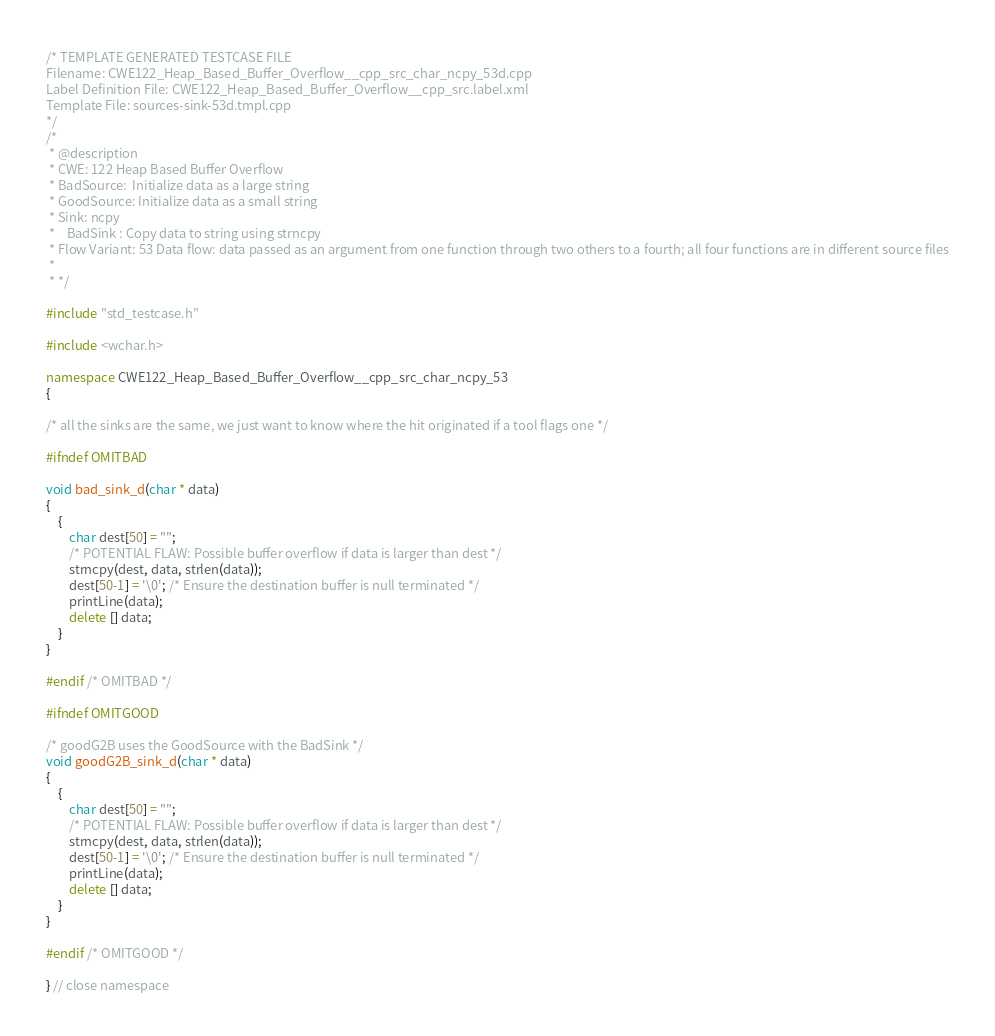Convert code to text. <code><loc_0><loc_0><loc_500><loc_500><_C++_>/* TEMPLATE GENERATED TESTCASE FILE
Filename: CWE122_Heap_Based_Buffer_Overflow__cpp_src_char_ncpy_53d.cpp
Label Definition File: CWE122_Heap_Based_Buffer_Overflow__cpp_src.label.xml
Template File: sources-sink-53d.tmpl.cpp
*/
/*
 * @description
 * CWE: 122 Heap Based Buffer Overflow
 * BadSource:  Initialize data as a large string
 * GoodSource: Initialize data as a small string
 * Sink: ncpy
 *    BadSink : Copy data to string using strncpy
 * Flow Variant: 53 Data flow: data passed as an argument from one function through two others to a fourth; all four functions are in different source files
 *
 * */

#include "std_testcase.h"

#include <wchar.h>

namespace CWE122_Heap_Based_Buffer_Overflow__cpp_src_char_ncpy_53
{

/* all the sinks are the same, we just want to know where the hit originated if a tool flags one */

#ifndef OMITBAD

void bad_sink_d(char * data)
{
    {
        char dest[50] = "";
        /* POTENTIAL FLAW: Possible buffer overflow if data is larger than dest */
        strncpy(dest, data, strlen(data));
        dest[50-1] = '\0'; /* Ensure the destination buffer is null terminated */
        printLine(data);
        delete [] data;
    }
}

#endif /* OMITBAD */

#ifndef OMITGOOD

/* goodG2B uses the GoodSource with the BadSink */
void goodG2B_sink_d(char * data)
{
    {
        char dest[50] = "";
        /* POTENTIAL FLAW: Possible buffer overflow if data is larger than dest */
        strncpy(dest, data, strlen(data));
        dest[50-1] = '\0'; /* Ensure the destination buffer is null terminated */
        printLine(data);
        delete [] data;
    }
}

#endif /* OMITGOOD */

} // close namespace
</code> 